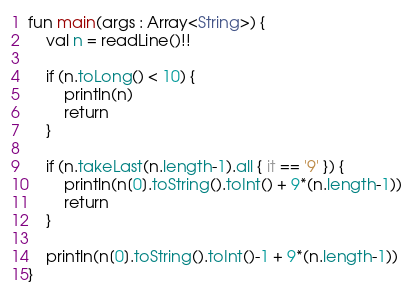Convert code to text. <code><loc_0><loc_0><loc_500><loc_500><_Kotlin_>fun main(args : Array<String>) {
    val n = readLine()!!

    if (n.toLong() < 10) {
        println(n)
        return
    }

    if (n.takeLast(n.length-1).all { it == '9' }) {
        println(n[0].toString().toInt() + 9*(n.length-1))
        return
    }

    println(n[0].toString().toInt()-1 + 9*(n.length-1))
}</code> 